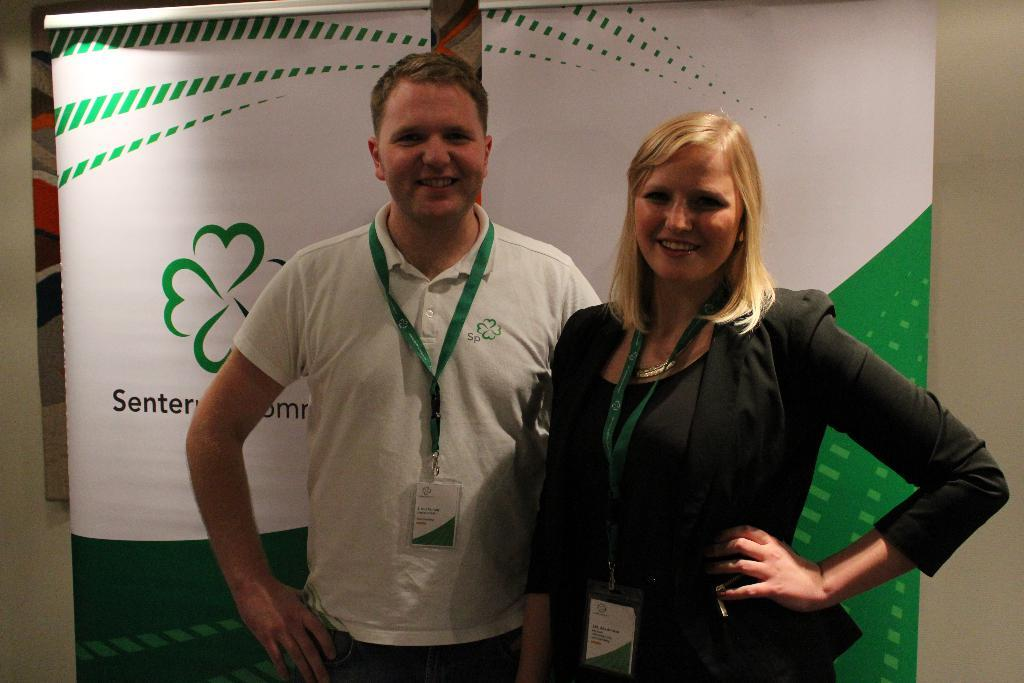How many people are in the image? There are two people in the image, a woman and a man. What are the people in the image doing? Both the woman and the man are standing. What can be seen on their clothes? They are wearing identity cards. What is their facial expression? They are both smiling. What can be seen in the background of the image? There are posters and a wall visible in the background. What type of teeth can be seen in the image? There are no teeth visible in the image, as the people are smiling but not showing their teeth. Are there any dolls present in the image? No, there are no dolls present in the image. 